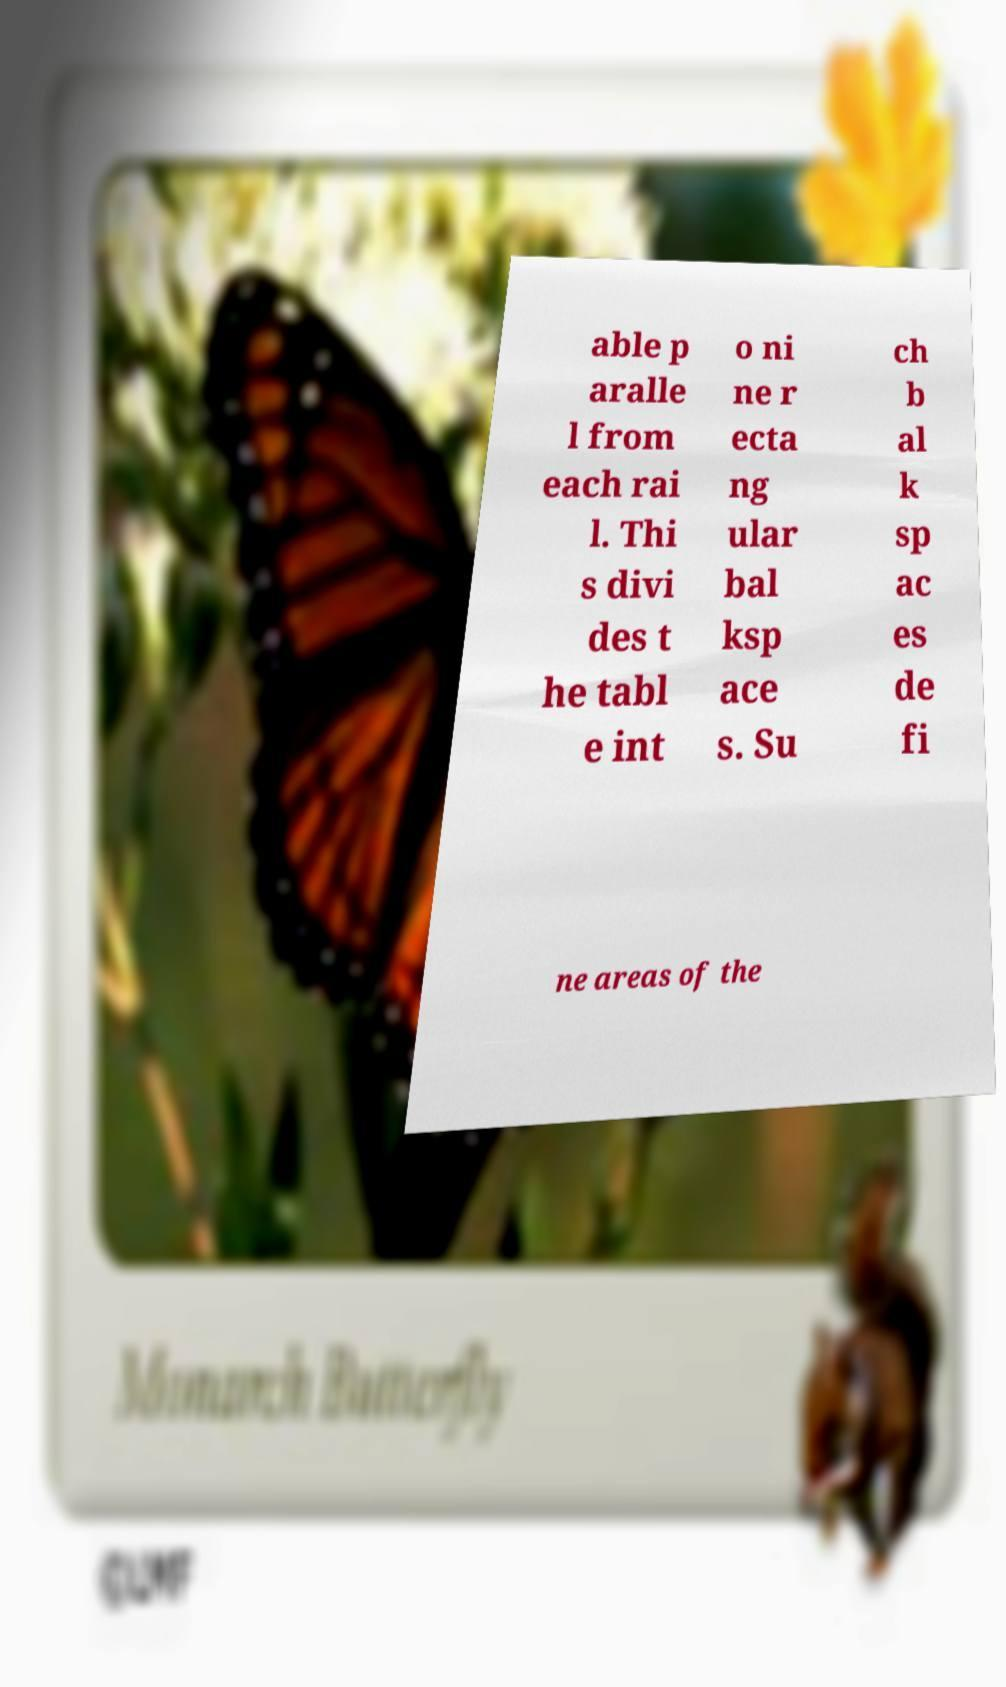I need the written content from this picture converted into text. Can you do that? able p aralle l from each rai l. Thi s divi des t he tabl e int o ni ne r ecta ng ular bal ksp ace s. Su ch b al k sp ac es de fi ne areas of the 